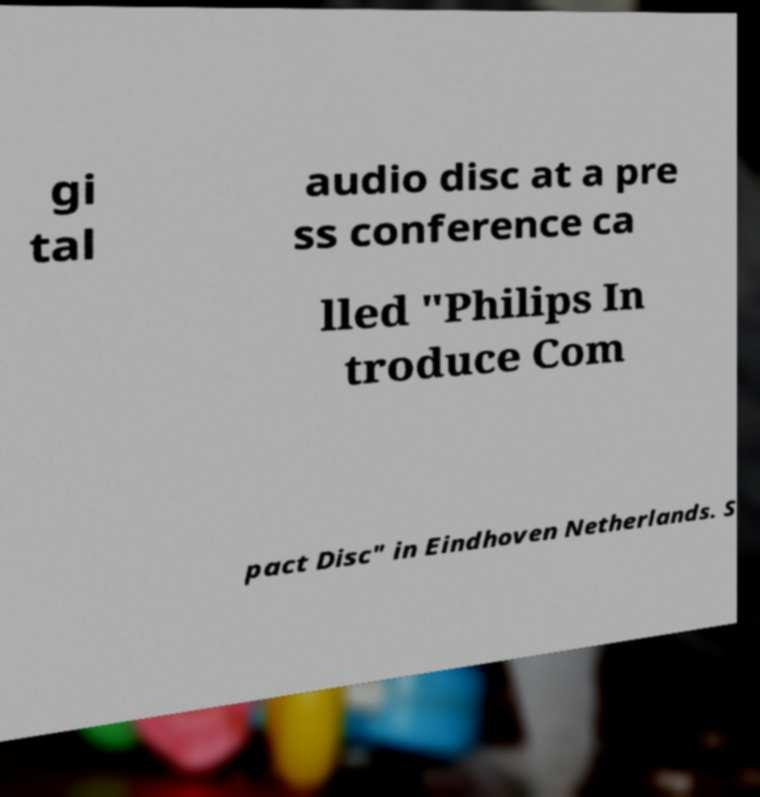Please identify and transcribe the text found in this image. gi tal audio disc at a pre ss conference ca lled "Philips In troduce Com pact Disc" in Eindhoven Netherlands. S 